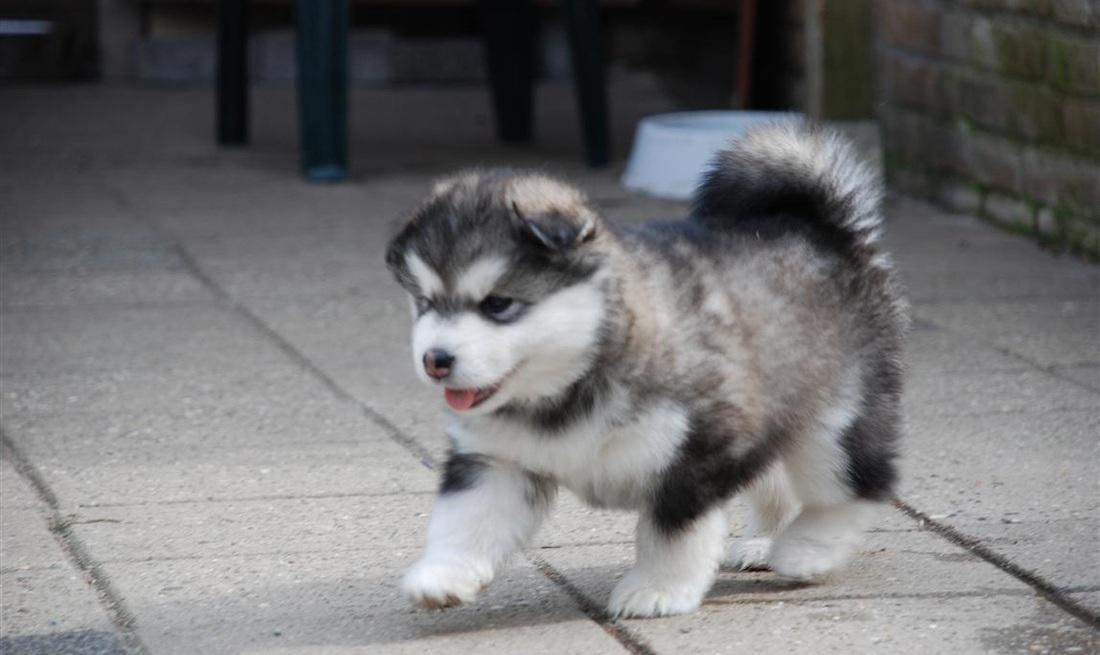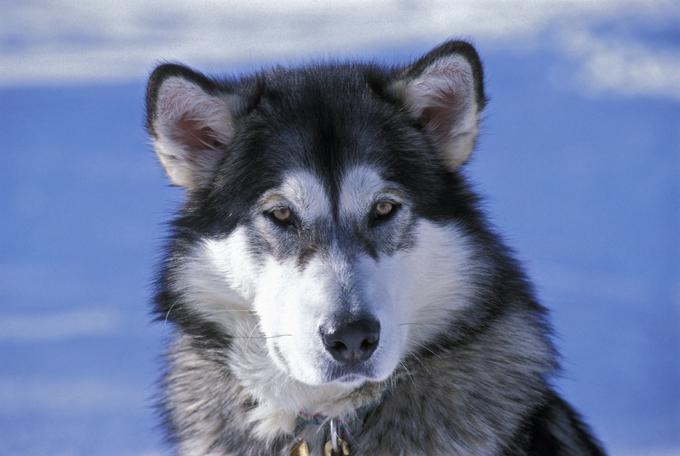The first image is the image on the left, the second image is the image on the right. Analyze the images presented: Is the assertion "The left image contains a puppy with forward-flopped ears, and the right image contains an adult dog with a closed mouth and non-blue eyes." valid? Answer yes or no. Yes. The first image is the image on the left, the second image is the image on the right. Assess this claim about the two images: "One dog is laying down.". Correct or not? Answer yes or no. No. 